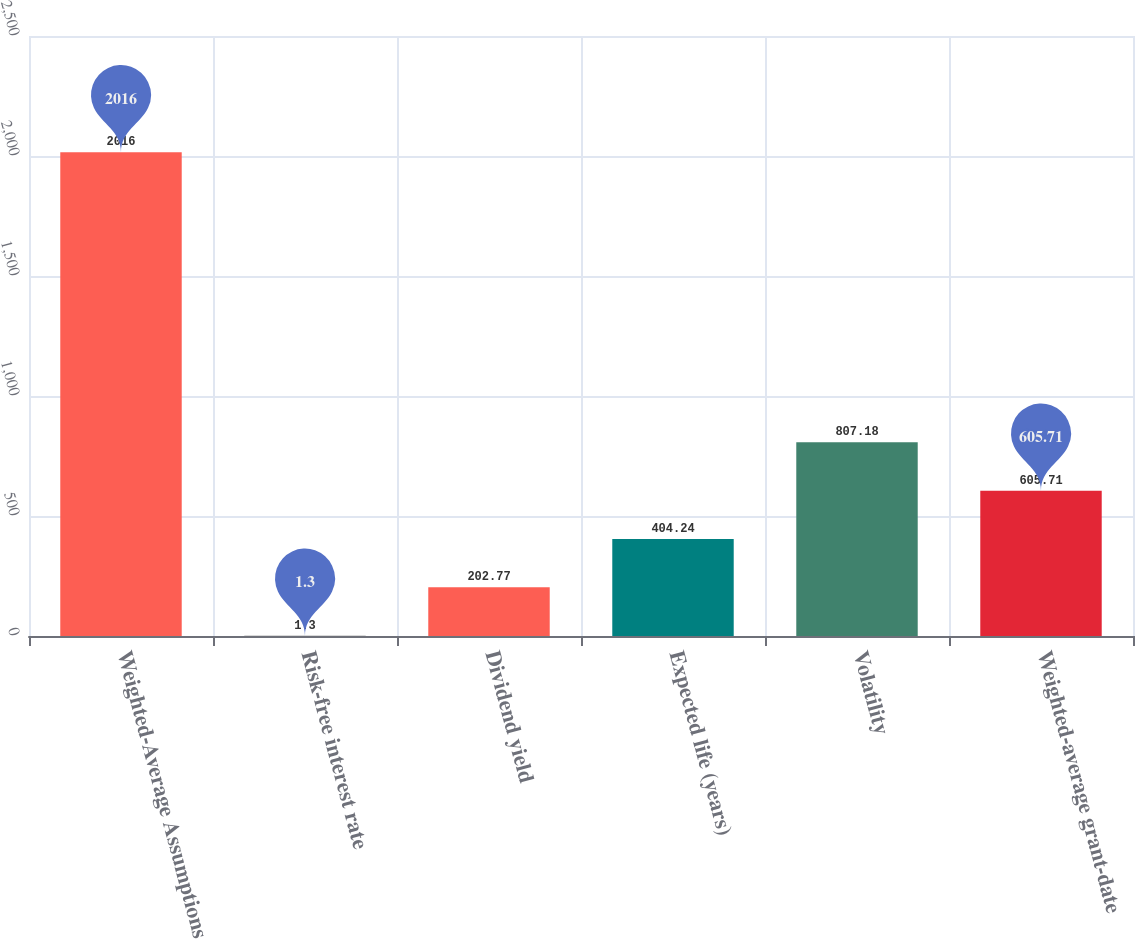Convert chart to OTSL. <chart><loc_0><loc_0><loc_500><loc_500><bar_chart><fcel>Weighted-Average Assumptions<fcel>Risk-free interest rate<fcel>Dividend yield<fcel>Expected life (years)<fcel>Volatility<fcel>Weighted-average grant-date<nl><fcel>2016<fcel>1.3<fcel>202.77<fcel>404.24<fcel>807.18<fcel>605.71<nl></chart> 